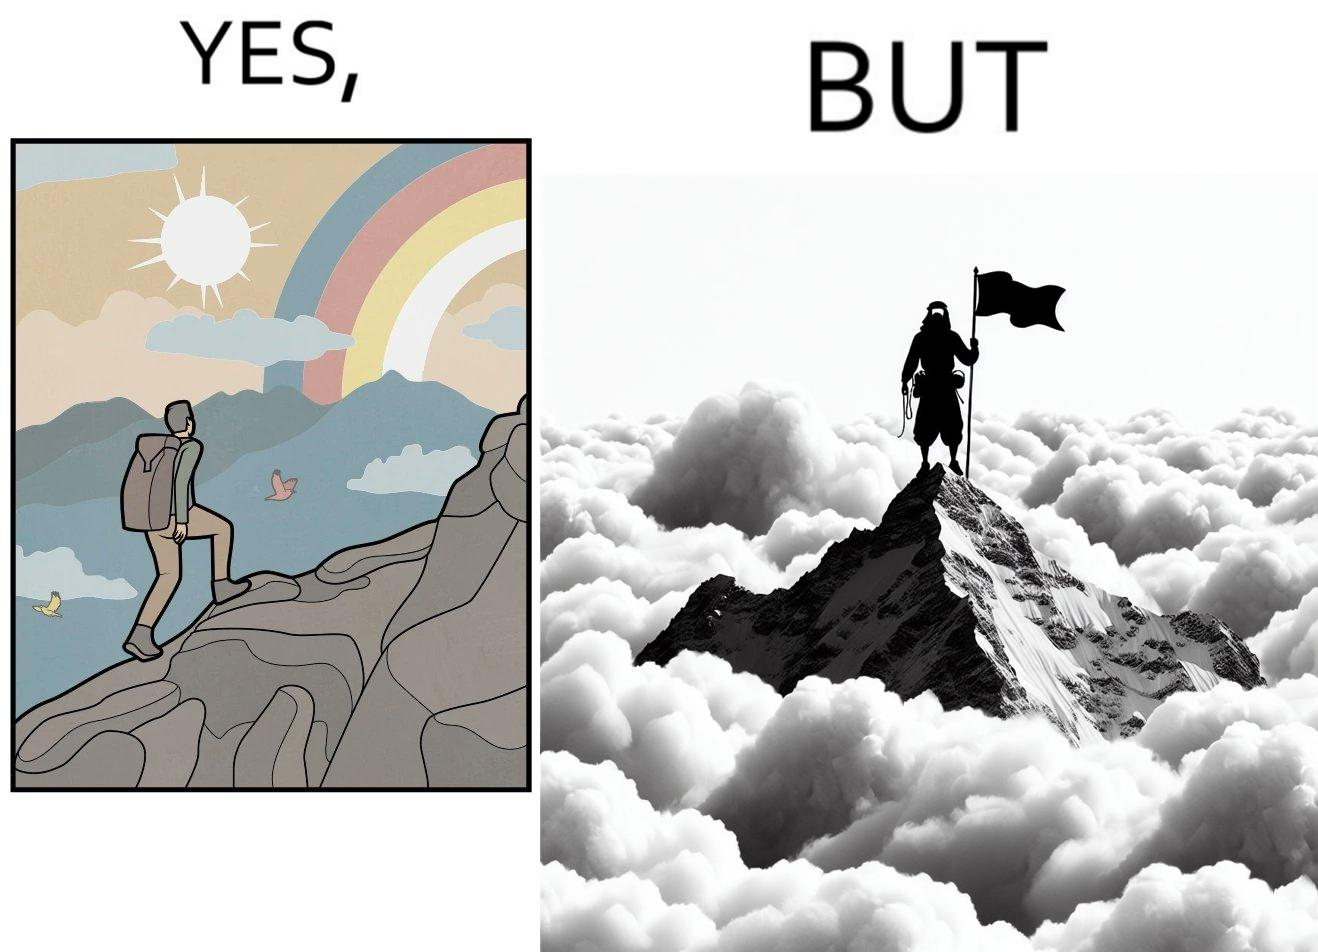Explain why this image is satirical. The image is ironic, because the mountaineer climbs up the mountain to view the world from the peak but due to so much cloud, at the top, nothing is visible whereas he was able to witness some awesome views while climbing up the mountain 